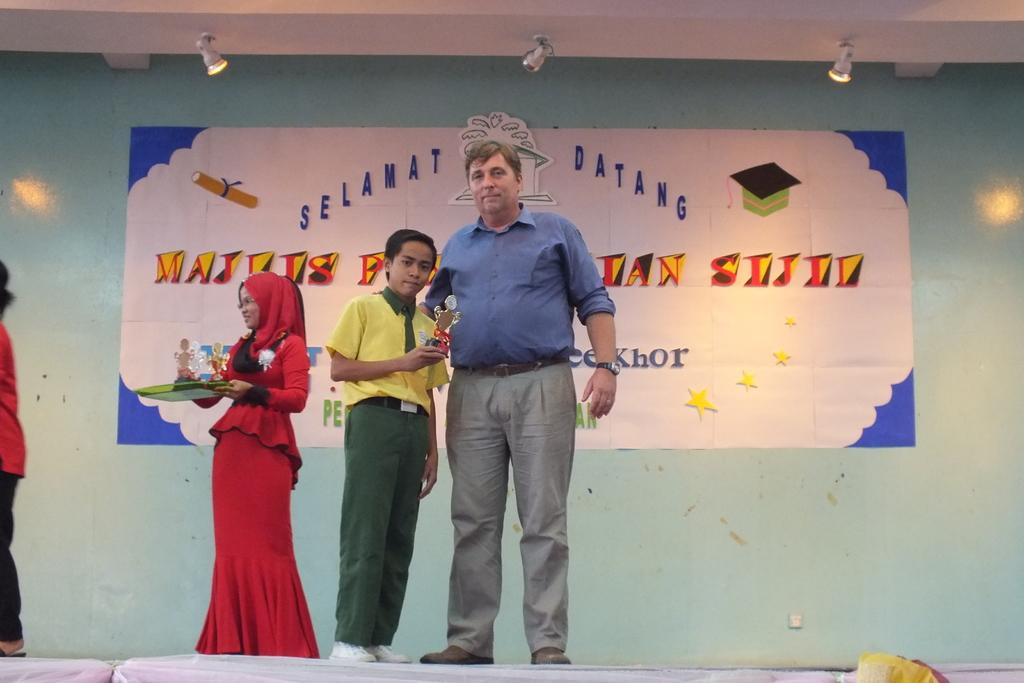How many people are present in the image? There are three people standing in the image. What are the people wearing? The people are wearing clothes. What can be seen on the wall in the image? There is a poster on the wall. What is visible at the top of the image? There are lights at the top of the image. What type of offer is being made by the crook in the image? There is no crook or offer present in the image; it features three people standing and a poster on the wall. What is the hope of the person in the image? There is no indication of a person's hope in the image, as it only shows three people standing and a poster on the wall. 